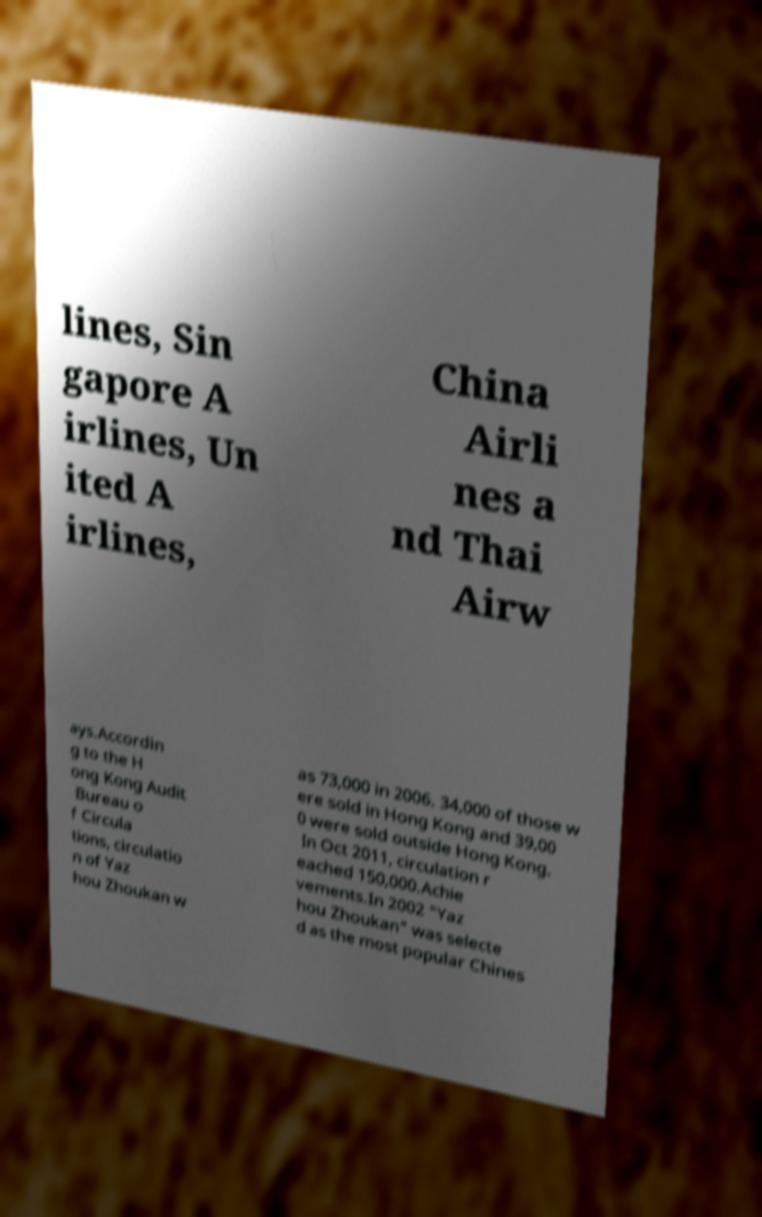Could you assist in decoding the text presented in this image and type it out clearly? lines, Sin gapore A irlines, Un ited A irlines, China Airli nes a nd Thai Airw ays.Accordin g to the H ong Kong Audit Bureau o f Circula tions, circulatio n of Yaz hou Zhoukan w as 73,000 in 2006. 34,000 of those w ere sold in Hong Kong and 39,00 0 were sold outside Hong Kong. In Oct 2011, circulation r eached 150,000.Achie vements.In 2002 "Yaz hou Zhoukan" was selecte d as the most popular Chines 